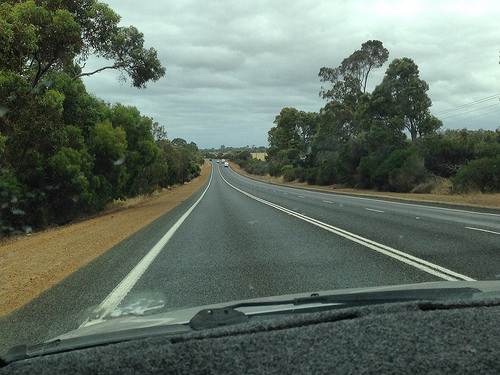<image>
Is there a road under the sky? Yes. The road is positioned underneath the sky, with the sky above it in the vertical space. Is the tree to the left of the road? Yes. From this viewpoint, the tree is positioned to the left side relative to the road. 